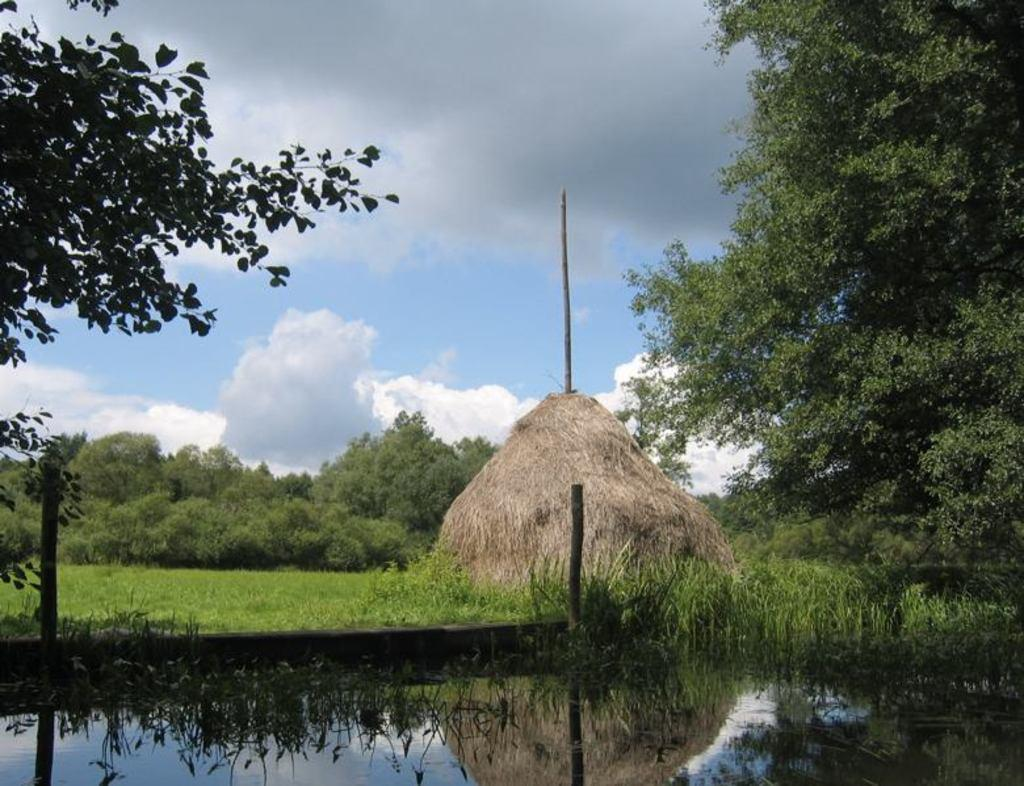What is at the bottom of the image? There is a surface of water at the bottom of the image. What can be found in the middle of the image? There is grass and trees present in the middle of the image. What is visible in the background of the image? The sky is visible in the background of the image. How would you describe the sky in the image? The sky is cloudy in the image. What type of flower is growing on the trees in the image? There are no flowers mentioned or visible on the trees in the image. What type of system is responsible for the cloudy sky in the image? The image does not provide information about a system responsible for the cloudy sky; it simply shows the sky as it appears. 